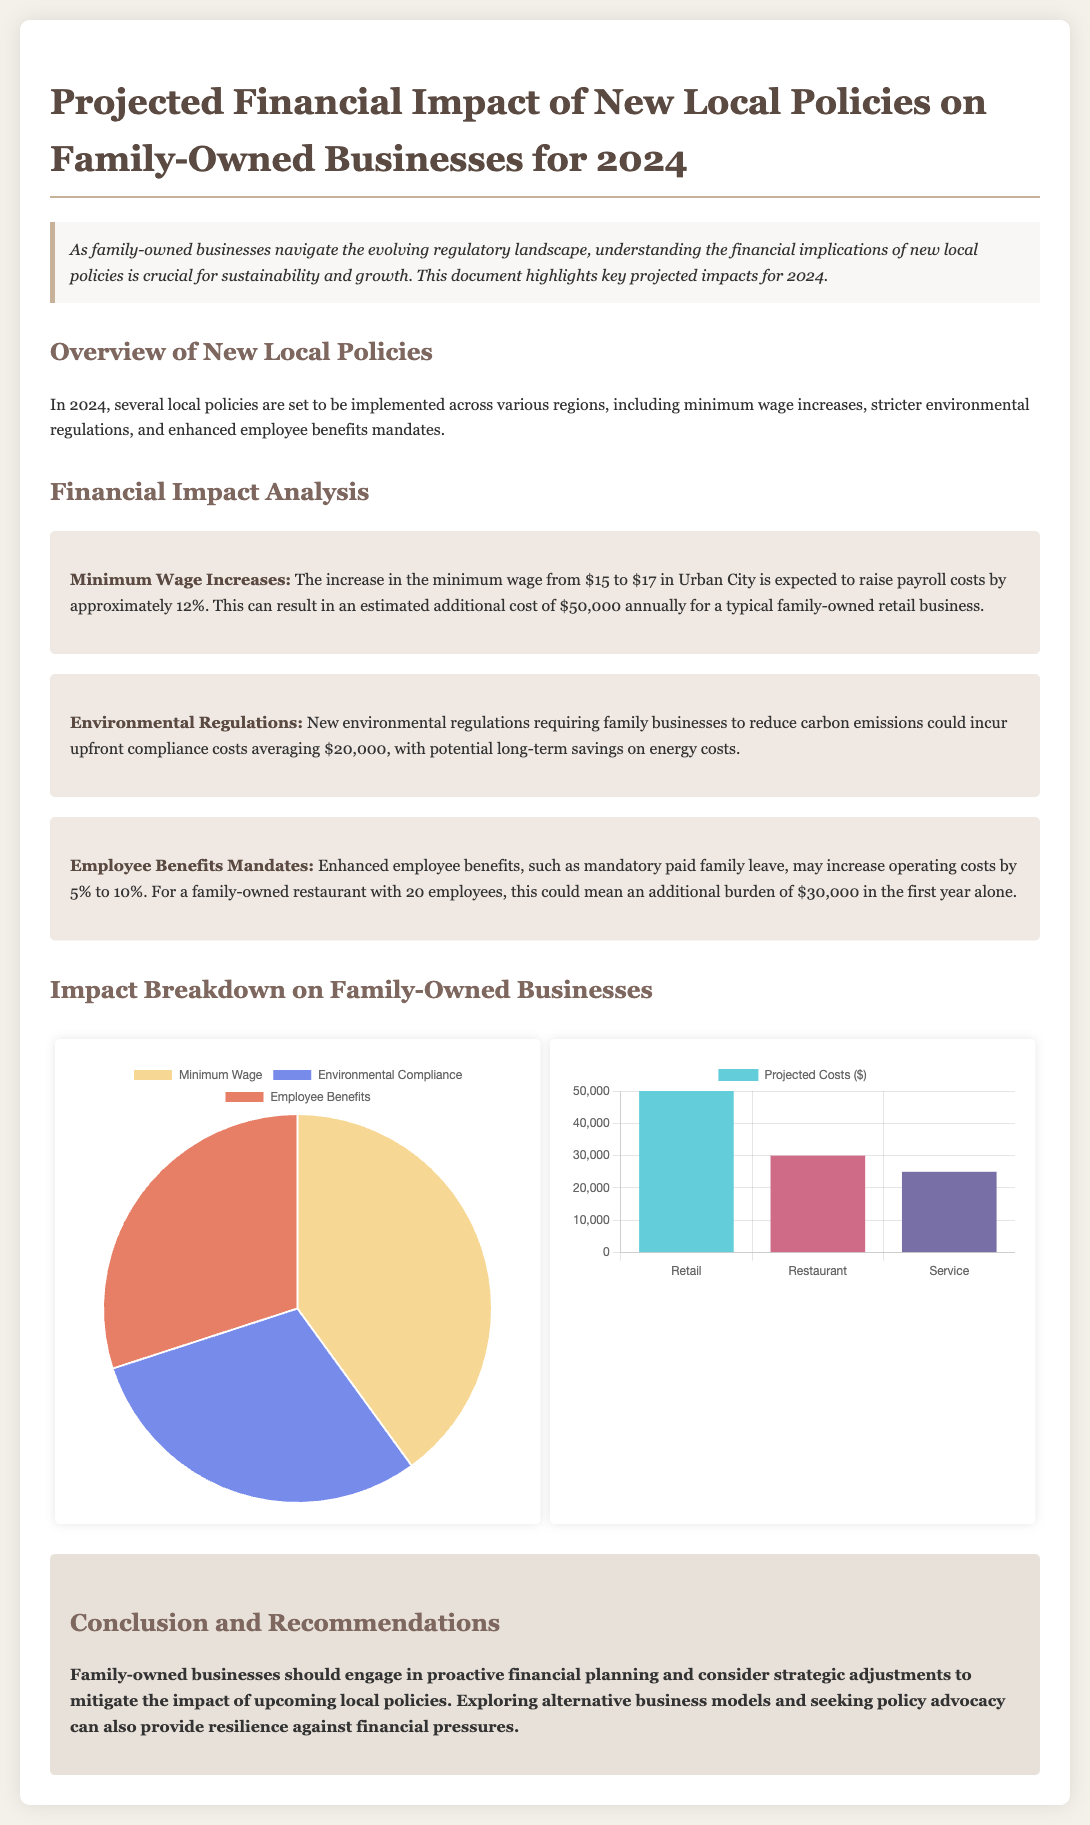What is the new minimum wage in Urban City? The document states that the minimum wage increases from $15 to $17 in Urban City.
Answer: $17 What is the expected annual payroll cost increase for a typical retail business? The document notes an estimated additional cost of $50,000 annually for a typical family-owned retail business due to the wage increase.
Answer: $50,000 What are the upfront compliance costs for environmental regulations? The document mentions that new environmental regulations could incur upfront compliance costs averaging $20,000.
Answer: $20,000 By how much could employee benefits increase operating costs? The document states that enhanced employee benefits may increase operating costs by 5% to 10%.
Answer: 5% to 10% What is the projected cost for a family-owned restaurant with 20 employees due to new benefits mandates? It highlights that enhanced employee benefits may incur an additional burden of $30,000 in the first year for a family-owned restaurant with 20 employees.
Answer: $30,000 What percentage of the impact is attributed to minimum wage increases in the pie chart? The pie chart indicates that 40% of the impact is attributed to minimum wage increases.
Answer: 40% Which business type has the highest projected costs according to the bar chart? The bar chart indicates that the retail business has the highest projected costs among the sectors.
Answer: Retail What type of planning should family-owned businesses engage in according to the conclusion? The conclusion advises family-owned businesses to engage in proactive financial planning.
Answer: Proactive financial planning What is the overall theme of the document regarding family-owned businesses? The document emphasizes the financial impact of new local policies on family-owned businesses.
Answer: Financial impact of new local policies 